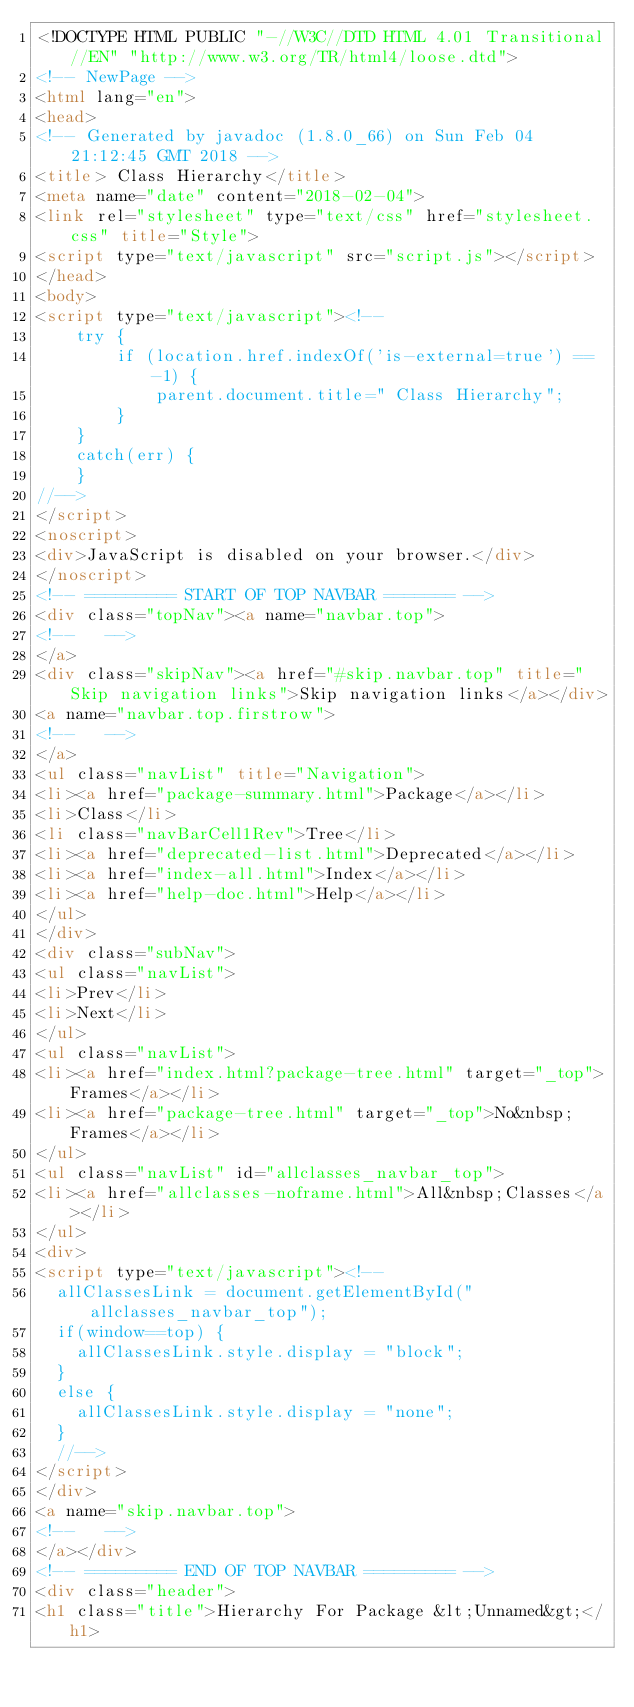Convert code to text. <code><loc_0><loc_0><loc_500><loc_500><_HTML_><!DOCTYPE HTML PUBLIC "-//W3C//DTD HTML 4.01 Transitional//EN" "http://www.w3.org/TR/html4/loose.dtd">
<!-- NewPage -->
<html lang="en">
<head>
<!-- Generated by javadoc (1.8.0_66) on Sun Feb 04 21:12:45 GMT 2018 -->
<title> Class Hierarchy</title>
<meta name="date" content="2018-02-04">
<link rel="stylesheet" type="text/css" href="stylesheet.css" title="Style">
<script type="text/javascript" src="script.js"></script>
</head>
<body>
<script type="text/javascript"><!--
    try {
        if (location.href.indexOf('is-external=true') == -1) {
            parent.document.title=" Class Hierarchy";
        }
    }
    catch(err) {
    }
//-->
</script>
<noscript>
<div>JavaScript is disabled on your browser.</div>
</noscript>
<!-- ========= START OF TOP NAVBAR ======= -->
<div class="topNav"><a name="navbar.top">
<!--   -->
</a>
<div class="skipNav"><a href="#skip.navbar.top" title="Skip navigation links">Skip navigation links</a></div>
<a name="navbar.top.firstrow">
<!--   -->
</a>
<ul class="navList" title="Navigation">
<li><a href="package-summary.html">Package</a></li>
<li>Class</li>
<li class="navBarCell1Rev">Tree</li>
<li><a href="deprecated-list.html">Deprecated</a></li>
<li><a href="index-all.html">Index</a></li>
<li><a href="help-doc.html">Help</a></li>
</ul>
</div>
<div class="subNav">
<ul class="navList">
<li>Prev</li>
<li>Next</li>
</ul>
<ul class="navList">
<li><a href="index.html?package-tree.html" target="_top">Frames</a></li>
<li><a href="package-tree.html" target="_top">No&nbsp;Frames</a></li>
</ul>
<ul class="navList" id="allclasses_navbar_top">
<li><a href="allclasses-noframe.html">All&nbsp;Classes</a></li>
</ul>
<div>
<script type="text/javascript"><!--
  allClassesLink = document.getElementById("allclasses_navbar_top");
  if(window==top) {
    allClassesLink.style.display = "block";
  }
  else {
    allClassesLink.style.display = "none";
  }
  //-->
</script>
</div>
<a name="skip.navbar.top">
<!--   -->
</a></div>
<!-- ========= END OF TOP NAVBAR ========= -->
<div class="header">
<h1 class="title">Hierarchy For Package &lt;Unnamed&gt;</h1></code> 